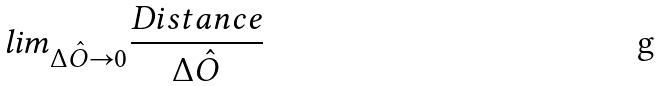<formula> <loc_0><loc_0><loc_500><loc_500>l i m _ { \Delta \hat { O } \rightarrow 0 } \frac { D i s t a n c e } { \Delta \hat { O } }</formula> 